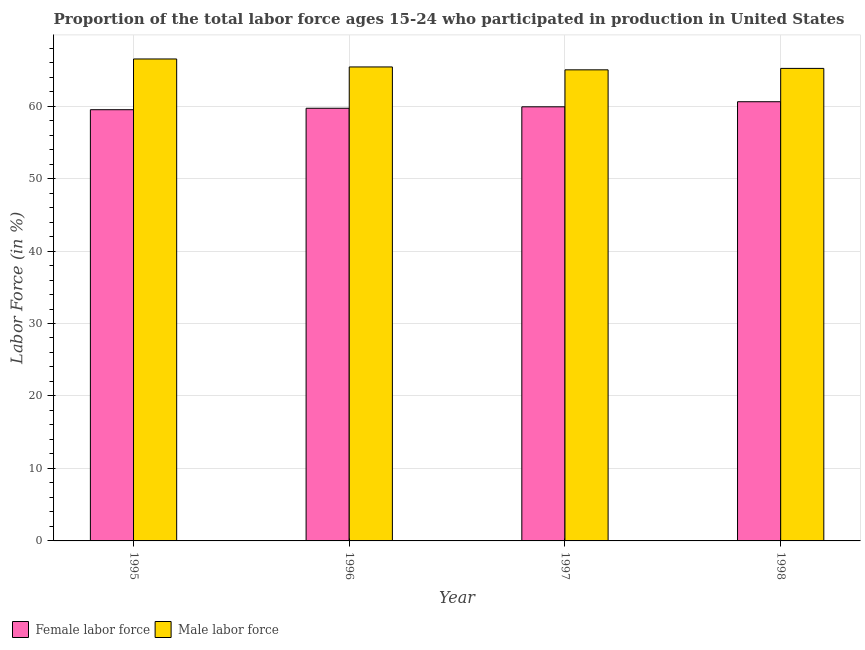Are the number of bars per tick equal to the number of legend labels?
Give a very brief answer. Yes. How many bars are there on the 4th tick from the left?
Keep it short and to the point. 2. How many bars are there on the 4th tick from the right?
Your response must be concise. 2. What is the label of the 3rd group of bars from the left?
Ensure brevity in your answer.  1997. In how many cases, is the number of bars for a given year not equal to the number of legend labels?
Ensure brevity in your answer.  0. What is the percentage of female labor force in 1997?
Offer a very short reply. 59.9. Across all years, what is the maximum percentage of female labor force?
Offer a very short reply. 60.6. Across all years, what is the minimum percentage of female labor force?
Offer a terse response. 59.5. In which year was the percentage of female labor force minimum?
Give a very brief answer. 1995. What is the total percentage of male labour force in the graph?
Offer a terse response. 262.1. What is the difference between the percentage of female labor force in 1995 and that in 1996?
Provide a short and direct response. -0.2. What is the difference between the percentage of female labor force in 1996 and the percentage of male labour force in 1998?
Provide a succinct answer. -0.9. What is the average percentage of male labour force per year?
Provide a short and direct response. 65.52. In how many years, is the percentage of female labor force greater than 18 %?
Offer a terse response. 4. What is the ratio of the percentage of female labor force in 1996 to that in 1997?
Provide a short and direct response. 1. Is the percentage of female labor force in 1995 less than that in 1997?
Provide a succinct answer. Yes. What is the difference between the highest and the second highest percentage of female labor force?
Provide a short and direct response. 0.7. What is the difference between the highest and the lowest percentage of female labor force?
Your answer should be very brief. 1.1. In how many years, is the percentage of female labor force greater than the average percentage of female labor force taken over all years?
Provide a short and direct response. 1. What does the 1st bar from the left in 1995 represents?
Provide a succinct answer. Female labor force. What does the 1st bar from the right in 1995 represents?
Your answer should be compact. Male labor force. How many years are there in the graph?
Give a very brief answer. 4. Are the values on the major ticks of Y-axis written in scientific E-notation?
Keep it short and to the point. No. Does the graph contain grids?
Your response must be concise. Yes. How many legend labels are there?
Provide a short and direct response. 2. What is the title of the graph?
Give a very brief answer. Proportion of the total labor force ages 15-24 who participated in production in United States. What is the label or title of the Y-axis?
Provide a succinct answer. Labor Force (in %). What is the Labor Force (in %) of Female labor force in 1995?
Your response must be concise. 59.5. What is the Labor Force (in %) in Male labor force in 1995?
Your response must be concise. 66.5. What is the Labor Force (in %) of Female labor force in 1996?
Your response must be concise. 59.7. What is the Labor Force (in %) in Male labor force in 1996?
Provide a succinct answer. 65.4. What is the Labor Force (in %) of Female labor force in 1997?
Your answer should be compact. 59.9. What is the Labor Force (in %) in Male labor force in 1997?
Ensure brevity in your answer.  65. What is the Labor Force (in %) of Female labor force in 1998?
Keep it short and to the point. 60.6. What is the Labor Force (in %) of Male labor force in 1998?
Keep it short and to the point. 65.2. Across all years, what is the maximum Labor Force (in %) of Female labor force?
Make the answer very short. 60.6. Across all years, what is the maximum Labor Force (in %) of Male labor force?
Your answer should be compact. 66.5. Across all years, what is the minimum Labor Force (in %) in Female labor force?
Make the answer very short. 59.5. What is the total Labor Force (in %) in Female labor force in the graph?
Your answer should be very brief. 239.7. What is the total Labor Force (in %) in Male labor force in the graph?
Offer a terse response. 262.1. What is the difference between the Labor Force (in %) of Male labor force in 1995 and that in 1996?
Ensure brevity in your answer.  1.1. What is the difference between the Labor Force (in %) in Female labor force in 1995 and that in 1997?
Your answer should be very brief. -0.4. What is the difference between the Labor Force (in %) in Male labor force in 1995 and that in 1997?
Give a very brief answer. 1.5. What is the difference between the Labor Force (in %) in Female labor force in 1995 and that in 1998?
Offer a terse response. -1.1. What is the difference between the Labor Force (in %) of Male labor force in 1997 and that in 1998?
Keep it short and to the point. -0.2. What is the difference between the Labor Force (in %) in Female labor force in 1995 and the Labor Force (in %) in Male labor force in 1997?
Offer a very short reply. -5.5. What is the difference between the Labor Force (in %) of Female labor force in 1996 and the Labor Force (in %) of Male labor force in 1997?
Your answer should be very brief. -5.3. What is the difference between the Labor Force (in %) of Female labor force in 1996 and the Labor Force (in %) of Male labor force in 1998?
Your response must be concise. -5.5. What is the average Labor Force (in %) in Female labor force per year?
Provide a succinct answer. 59.92. What is the average Labor Force (in %) of Male labor force per year?
Your response must be concise. 65.53. In the year 1998, what is the difference between the Labor Force (in %) of Female labor force and Labor Force (in %) of Male labor force?
Give a very brief answer. -4.6. What is the ratio of the Labor Force (in %) of Female labor force in 1995 to that in 1996?
Your answer should be compact. 1. What is the ratio of the Labor Force (in %) in Male labor force in 1995 to that in 1996?
Provide a succinct answer. 1.02. What is the ratio of the Labor Force (in %) of Male labor force in 1995 to that in 1997?
Offer a very short reply. 1.02. What is the ratio of the Labor Force (in %) in Female labor force in 1995 to that in 1998?
Keep it short and to the point. 0.98. What is the ratio of the Labor Force (in %) in Male labor force in 1995 to that in 1998?
Your answer should be compact. 1.02. What is the ratio of the Labor Force (in %) in Female labor force in 1996 to that in 1997?
Your answer should be compact. 1. What is the ratio of the Labor Force (in %) in Female labor force in 1996 to that in 1998?
Make the answer very short. 0.99. What is the ratio of the Labor Force (in %) of Male labor force in 1996 to that in 1998?
Ensure brevity in your answer.  1. What is the ratio of the Labor Force (in %) in Female labor force in 1997 to that in 1998?
Give a very brief answer. 0.99. What is the ratio of the Labor Force (in %) of Male labor force in 1997 to that in 1998?
Your answer should be very brief. 1. What is the difference between the highest and the second highest Labor Force (in %) in Female labor force?
Offer a very short reply. 0.7. What is the difference between the highest and the second highest Labor Force (in %) in Male labor force?
Your answer should be compact. 1.1. 